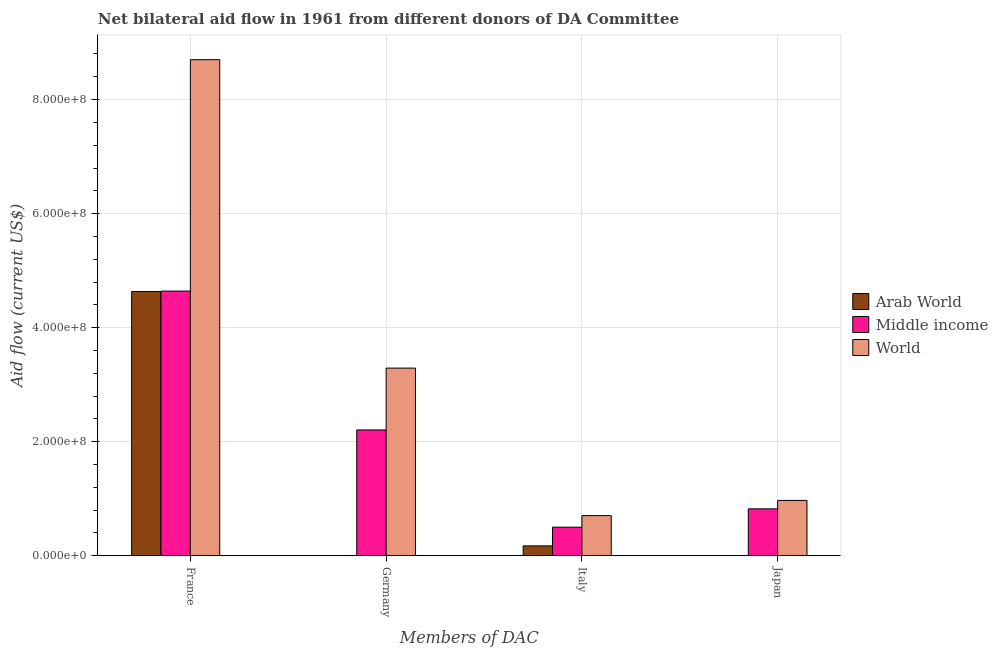How many different coloured bars are there?
Keep it short and to the point. 3. How many groups of bars are there?
Make the answer very short. 4. Are the number of bars on each tick of the X-axis equal?
Your answer should be compact. No. How many bars are there on the 4th tick from the left?
Provide a short and direct response. 3. What is the label of the 3rd group of bars from the left?
Make the answer very short. Italy. What is the amount of aid given by japan in World?
Offer a very short reply. 9.71e+07. Across all countries, what is the maximum amount of aid given by italy?
Your response must be concise. 7.04e+07. Across all countries, what is the minimum amount of aid given by italy?
Give a very brief answer. 1.74e+07. In which country was the amount of aid given by italy maximum?
Ensure brevity in your answer.  World. What is the total amount of aid given by japan in the graph?
Give a very brief answer. 1.80e+08. What is the difference between the amount of aid given by italy in World and that in Middle income?
Provide a succinct answer. 2.02e+07. What is the difference between the amount of aid given by france in Middle income and the amount of aid given by italy in Arab World?
Your response must be concise. 4.47e+08. What is the average amount of aid given by france per country?
Keep it short and to the point. 5.99e+08. What is the difference between the amount of aid given by japan and amount of aid given by france in World?
Your answer should be compact. -7.73e+08. In how many countries, is the amount of aid given by italy greater than 760000000 US$?
Ensure brevity in your answer.  0. What is the ratio of the amount of aid given by japan in Middle income to that in Arab World?
Your answer should be very brief. 1029. What is the difference between the highest and the second highest amount of aid given by italy?
Your response must be concise. 2.02e+07. What is the difference between the highest and the lowest amount of aid given by france?
Your response must be concise. 4.06e+08. In how many countries, is the amount of aid given by italy greater than the average amount of aid given by italy taken over all countries?
Provide a succinct answer. 2. What is the difference between two consecutive major ticks on the Y-axis?
Give a very brief answer. 2.00e+08. Are the values on the major ticks of Y-axis written in scientific E-notation?
Provide a short and direct response. Yes. Does the graph contain any zero values?
Offer a very short reply. Yes. Does the graph contain grids?
Provide a short and direct response. Yes. What is the title of the graph?
Your answer should be compact. Net bilateral aid flow in 1961 from different donors of DA Committee. What is the label or title of the X-axis?
Offer a very short reply. Members of DAC. What is the Aid flow (current US$) in Arab World in France?
Ensure brevity in your answer.  4.64e+08. What is the Aid flow (current US$) in Middle income in France?
Offer a very short reply. 4.64e+08. What is the Aid flow (current US$) in World in France?
Offer a very short reply. 8.70e+08. What is the Aid flow (current US$) of Middle income in Germany?
Your answer should be compact. 2.21e+08. What is the Aid flow (current US$) of World in Germany?
Give a very brief answer. 3.29e+08. What is the Aid flow (current US$) of Arab World in Italy?
Provide a short and direct response. 1.74e+07. What is the Aid flow (current US$) of Middle income in Italy?
Your answer should be compact. 5.02e+07. What is the Aid flow (current US$) of World in Italy?
Your answer should be compact. 7.04e+07. What is the Aid flow (current US$) of Middle income in Japan?
Keep it short and to the point. 8.23e+07. What is the Aid flow (current US$) of World in Japan?
Your response must be concise. 9.71e+07. Across all Members of DAC, what is the maximum Aid flow (current US$) of Arab World?
Offer a terse response. 4.64e+08. Across all Members of DAC, what is the maximum Aid flow (current US$) in Middle income?
Provide a succinct answer. 4.64e+08. Across all Members of DAC, what is the maximum Aid flow (current US$) of World?
Your response must be concise. 8.70e+08. Across all Members of DAC, what is the minimum Aid flow (current US$) in Arab World?
Provide a short and direct response. 0. Across all Members of DAC, what is the minimum Aid flow (current US$) of Middle income?
Keep it short and to the point. 5.02e+07. Across all Members of DAC, what is the minimum Aid flow (current US$) of World?
Offer a terse response. 7.04e+07. What is the total Aid flow (current US$) in Arab World in the graph?
Provide a short and direct response. 4.81e+08. What is the total Aid flow (current US$) of Middle income in the graph?
Provide a succinct answer. 8.17e+08. What is the total Aid flow (current US$) in World in the graph?
Provide a short and direct response. 1.37e+09. What is the difference between the Aid flow (current US$) of Middle income in France and that in Germany?
Make the answer very short. 2.44e+08. What is the difference between the Aid flow (current US$) of World in France and that in Germany?
Make the answer very short. 5.41e+08. What is the difference between the Aid flow (current US$) of Arab World in France and that in Italy?
Provide a short and direct response. 4.46e+08. What is the difference between the Aid flow (current US$) of Middle income in France and that in Italy?
Keep it short and to the point. 4.14e+08. What is the difference between the Aid flow (current US$) in World in France and that in Italy?
Your answer should be compact. 8.00e+08. What is the difference between the Aid flow (current US$) in Arab World in France and that in Japan?
Your answer should be compact. 4.63e+08. What is the difference between the Aid flow (current US$) in Middle income in France and that in Japan?
Your answer should be compact. 3.82e+08. What is the difference between the Aid flow (current US$) of World in France and that in Japan?
Give a very brief answer. 7.73e+08. What is the difference between the Aid flow (current US$) of Middle income in Germany and that in Italy?
Provide a short and direct response. 1.71e+08. What is the difference between the Aid flow (current US$) in World in Germany and that in Italy?
Keep it short and to the point. 2.59e+08. What is the difference between the Aid flow (current US$) in Middle income in Germany and that in Japan?
Offer a terse response. 1.38e+08. What is the difference between the Aid flow (current US$) in World in Germany and that in Japan?
Provide a short and direct response. 2.32e+08. What is the difference between the Aid flow (current US$) in Arab World in Italy and that in Japan?
Ensure brevity in your answer.  1.73e+07. What is the difference between the Aid flow (current US$) of Middle income in Italy and that in Japan?
Offer a very short reply. -3.22e+07. What is the difference between the Aid flow (current US$) of World in Italy and that in Japan?
Provide a succinct answer. -2.67e+07. What is the difference between the Aid flow (current US$) of Arab World in France and the Aid flow (current US$) of Middle income in Germany?
Give a very brief answer. 2.43e+08. What is the difference between the Aid flow (current US$) in Arab World in France and the Aid flow (current US$) in World in Germany?
Your answer should be very brief. 1.34e+08. What is the difference between the Aid flow (current US$) in Middle income in France and the Aid flow (current US$) in World in Germany?
Give a very brief answer. 1.35e+08. What is the difference between the Aid flow (current US$) of Arab World in France and the Aid flow (current US$) of Middle income in Italy?
Offer a terse response. 4.13e+08. What is the difference between the Aid flow (current US$) in Arab World in France and the Aid flow (current US$) in World in Italy?
Offer a terse response. 3.93e+08. What is the difference between the Aid flow (current US$) in Middle income in France and the Aid flow (current US$) in World in Italy?
Provide a succinct answer. 3.94e+08. What is the difference between the Aid flow (current US$) in Arab World in France and the Aid flow (current US$) in Middle income in Japan?
Your response must be concise. 3.81e+08. What is the difference between the Aid flow (current US$) of Arab World in France and the Aid flow (current US$) of World in Japan?
Your answer should be compact. 3.66e+08. What is the difference between the Aid flow (current US$) in Middle income in France and the Aid flow (current US$) in World in Japan?
Offer a terse response. 3.67e+08. What is the difference between the Aid flow (current US$) of Middle income in Germany and the Aid flow (current US$) of World in Italy?
Ensure brevity in your answer.  1.50e+08. What is the difference between the Aid flow (current US$) of Middle income in Germany and the Aid flow (current US$) of World in Japan?
Your answer should be compact. 1.24e+08. What is the difference between the Aid flow (current US$) in Arab World in Italy and the Aid flow (current US$) in Middle income in Japan?
Your answer should be compact. -6.49e+07. What is the difference between the Aid flow (current US$) of Arab World in Italy and the Aid flow (current US$) of World in Japan?
Make the answer very short. -7.97e+07. What is the difference between the Aid flow (current US$) in Middle income in Italy and the Aid flow (current US$) in World in Japan?
Your answer should be compact. -4.69e+07. What is the average Aid flow (current US$) in Arab World per Members of DAC?
Ensure brevity in your answer.  1.20e+08. What is the average Aid flow (current US$) of Middle income per Members of DAC?
Provide a short and direct response. 2.04e+08. What is the average Aid flow (current US$) in World per Members of DAC?
Provide a short and direct response. 3.42e+08. What is the difference between the Aid flow (current US$) in Arab World and Aid flow (current US$) in Middle income in France?
Provide a succinct answer. -7.00e+05. What is the difference between the Aid flow (current US$) of Arab World and Aid flow (current US$) of World in France?
Your answer should be very brief. -4.06e+08. What is the difference between the Aid flow (current US$) in Middle income and Aid flow (current US$) in World in France?
Make the answer very short. -4.06e+08. What is the difference between the Aid flow (current US$) of Middle income and Aid flow (current US$) of World in Germany?
Offer a terse response. -1.08e+08. What is the difference between the Aid flow (current US$) in Arab World and Aid flow (current US$) in Middle income in Italy?
Make the answer very short. -3.28e+07. What is the difference between the Aid flow (current US$) of Arab World and Aid flow (current US$) of World in Italy?
Offer a terse response. -5.30e+07. What is the difference between the Aid flow (current US$) in Middle income and Aid flow (current US$) in World in Italy?
Your answer should be very brief. -2.02e+07. What is the difference between the Aid flow (current US$) of Arab World and Aid flow (current US$) of Middle income in Japan?
Keep it short and to the point. -8.22e+07. What is the difference between the Aid flow (current US$) of Arab World and Aid flow (current US$) of World in Japan?
Your answer should be very brief. -9.70e+07. What is the difference between the Aid flow (current US$) of Middle income and Aid flow (current US$) of World in Japan?
Your response must be concise. -1.48e+07. What is the ratio of the Aid flow (current US$) in Middle income in France to that in Germany?
Your answer should be compact. 2.1. What is the ratio of the Aid flow (current US$) of World in France to that in Germany?
Provide a succinct answer. 2.64. What is the ratio of the Aid flow (current US$) of Arab World in France to that in Italy?
Make the answer very short. 26.64. What is the ratio of the Aid flow (current US$) of Middle income in France to that in Italy?
Provide a succinct answer. 9.25. What is the ratio of the Aid flow (current US$) of World in France to that in Italy?
Keep it short and to the point. 12.35. What is the ratio of the Aid flow (current US$) of Arab World in France to that in Japan?
Your response must be concise. 5793.75. What is the ratio of the Aid flow (current US$) of Middle income in France to that in Japan?
Give a very brief answer. 5.64. What is the ratio of the Aid flow (current US$) of World in France to that in Japan?
Provide a short and direct response. 8.96. What is the ratio of the Aid flow (current US$) in Middle income in Germany to that in Italy?
Provide a succinct answer. 4.4. What is the ratio of the Aid flow (current US$) in World in Germany to that in Italy?
Provide a short and direct response. 4.67. What is the ratio of the Aid flow (current US$) of Middle income in Germany to that in Japan?
Your answer should be compact. 2.68. What is the ratio of the Aid flow (current US$) of World in Germany to that in Japan?
Give a very brief answer. 3.39. What is the ratio of the Aid flow (current US$) of Arab World in Italy to that in Japan?
Your response must be concise. 217.5. What is the ratio of the Aid flow (current US$) of Middle income in Italy to that in Japan?
Offer a terse response. 0.61. What is the ratio of the Aid flow (current US$) of World in Italy to that in Japan?
Make the answer very short. 0.73. What is the difference between the highest and the second highest Aid flow (current US$) of Arab World?
Give a very brief answer. 4.46e+08. What is the difference between the highest and the second highest Aid flow (current US$) of Middle income?
Offer a very short reply. 2.44e+08. What is the difference between the highest and the second highest Aid flow (current US$) of World?
Offer a terse response. 5.41e+08. What is the difference between the highest and the lowest Aid flow (current US$) of Arab World?
Give a very brief answer. 4.64e+08. What is the difference between the highest and the lowest Aid flow (current US$) in Middle income?
Your answer should be compact. 4.14e+08. What is the difference between the highest and the lowest Aid flow (current US$) in World?
Give a very brief answer. 8.00e+08. 